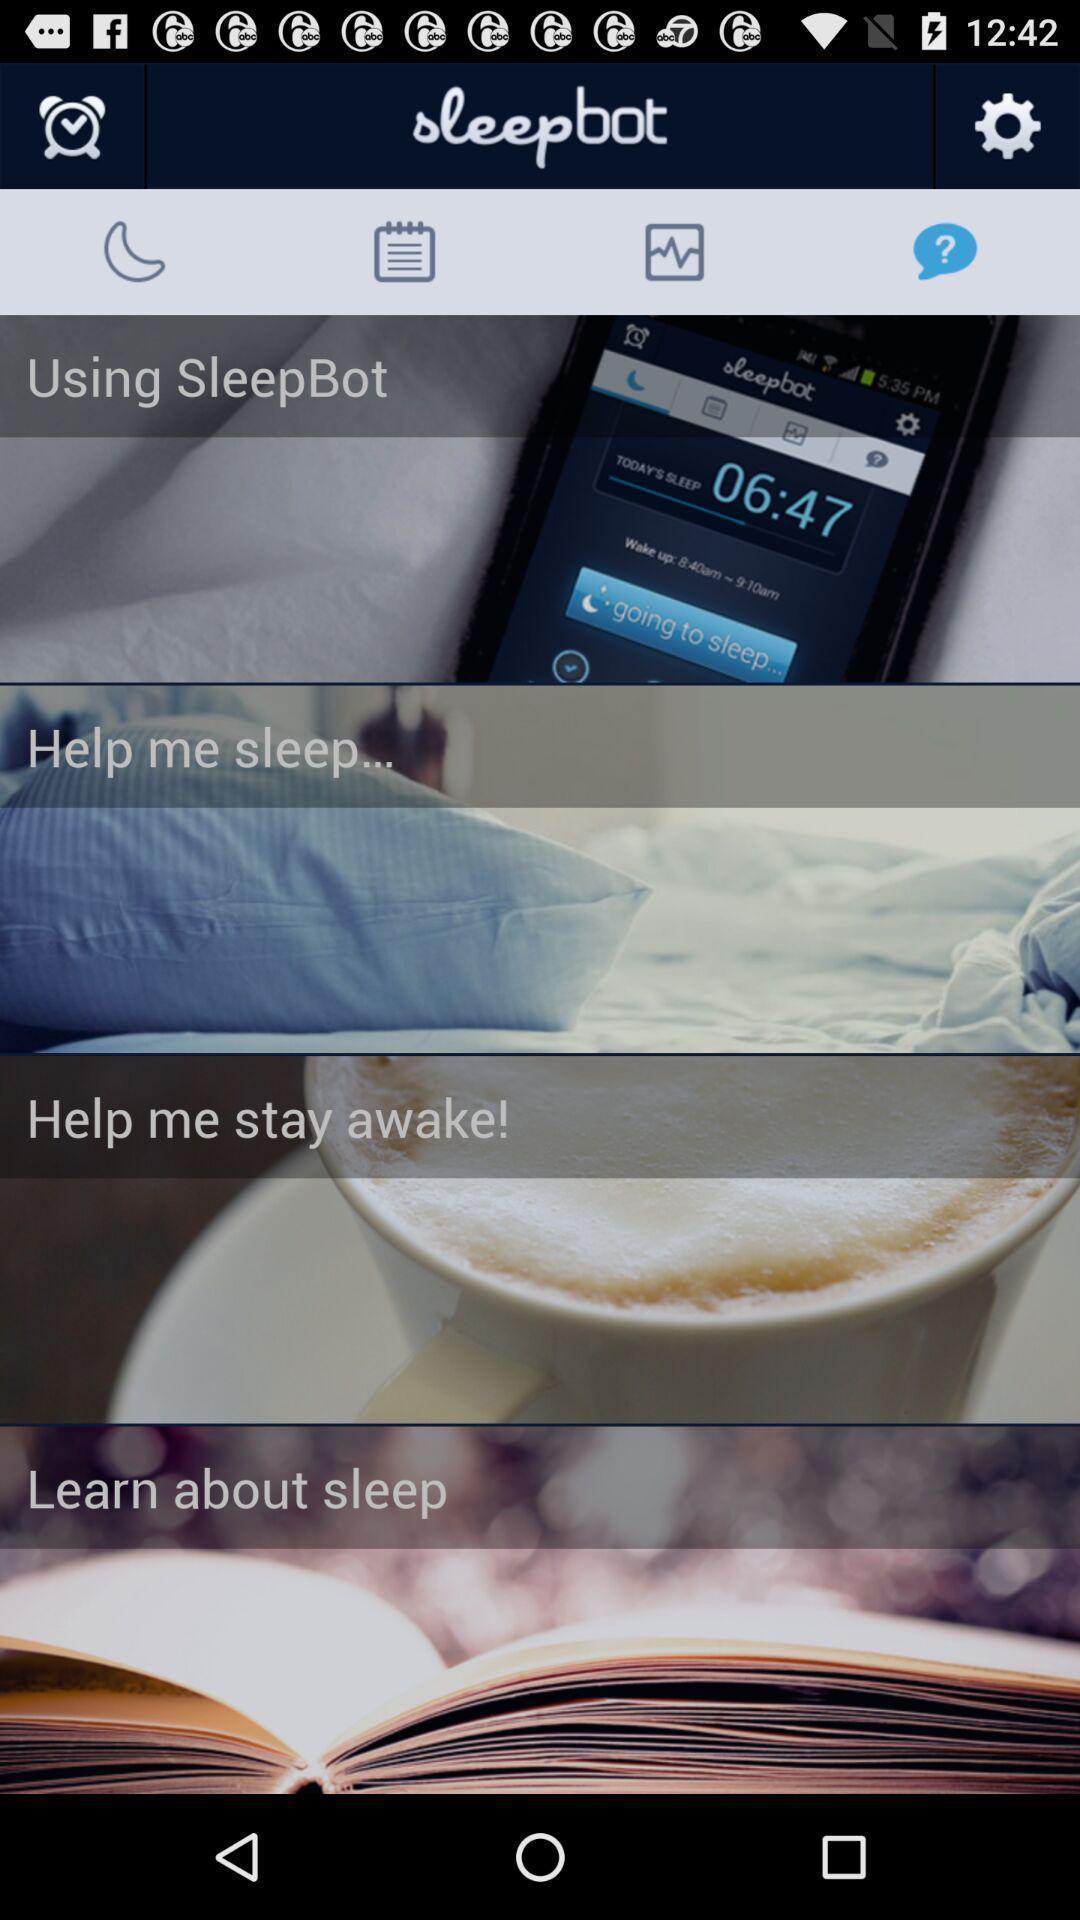Please provide a description for this image. Page showing multiple options. 